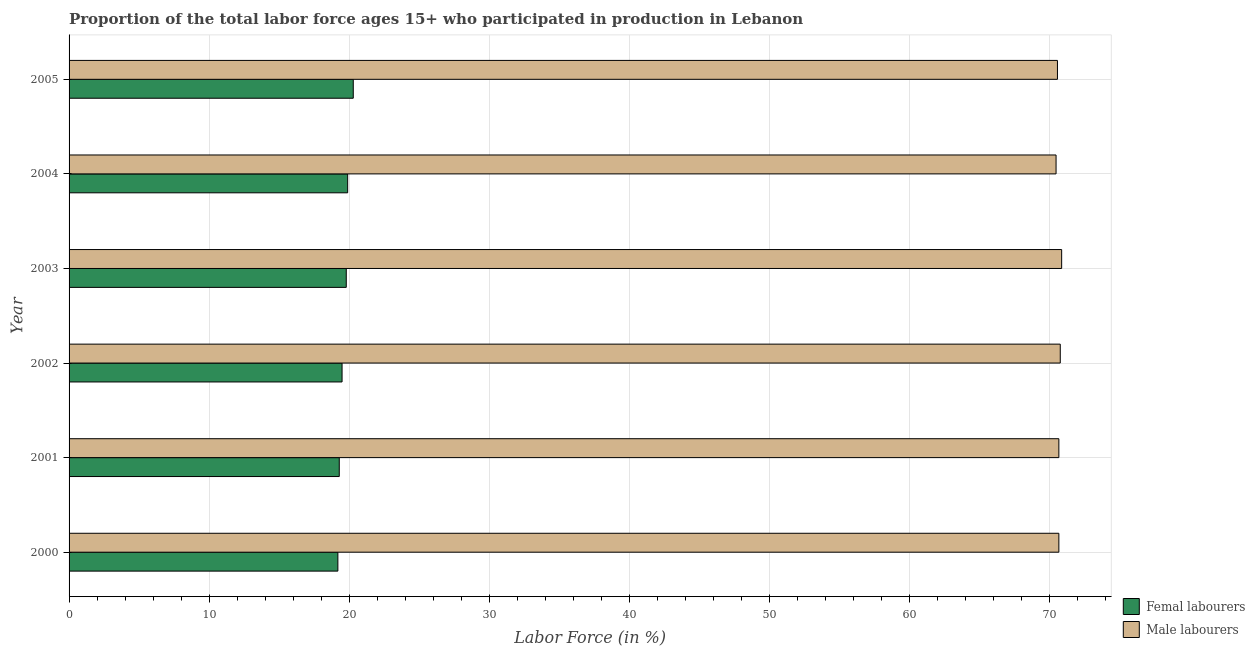How many different coloured bars are there?
Keep it short and to the point. 2. How many groups of bars are there?
Provide a short and direct response. 6. How many bars are there on the 4th tick from the top?
Your response must be concise. 2. How many bars are there on the 3rd tick from the bottom?
Keep it short and to the point. 2. In how many cases, is the number of bars for a given year not equal to the number of legend labels?
Provide a short and direct response. 0. What is the percentage of female labor force in 2004?
Offer a very short reply. 19.9. Across all years, what is the maximum percentage of male labour force?
Your answer should be very brief. 70.9. Across all years, what is the minimum percentage of male labour force?
Provide a succinct answer. 70.5. In which year was the percentage of female labor force maximum?
Your answer should be very brief. 2005. What is the total percentage of female labor force in the graph?
Your response must be concise. 118. What is the difference between the percentage of male labour force in 2000 and that in 2002?
Keep it short and to the point. -0.1. What is the difference between the percentage of male labour force in 2000 and the percentage of female labor force in 2005?
Offer a very short reply. 50.4. What is the average percentage of male labour force per year?
Give a very brief answer. 70.7. In the year 2004, what is the difference between the percentage of female labor force and percentage of male labour force?
Make the answer very short. -50.6. In how many years, is the percentage of female labor force greater than 30 %?
Give a very brief answer. 0. What is the ratio of the percentage of male labour force in 2003 to that in 2004?
Provide a short and direct response. 1.01. What is the difference between the highest and the second highest percentage of female labor force?
Your response must be concise. 0.4. What is the difference between the highest and the lowest percentage of female labor force?
Provide a succinct answer. 1.1. What does the 2nd bar from the top in 2005 represents?
Your response must be concise. Femal labourers. What does the 2nd bar from the bottom in 2002 represents?
Your response must be concise. Male labourers. How many bars are there?
Offer a very short reply. 12. What is the difference between two consecutive major ticks on the X-axis?
Provide a succinct answer. 10. Does the graph contain grids?
Provide a short and direct response. Yes. Where does the legend appear in the graph?
Ensure brevity in your answer.  Bottom right. How many legend labels are there?
Your response must be concise. 2. How are the legend labels stacked?
Offer a terse response. Vertical. What is the title of the graph?
Provide a short and direct response. Proportion of the total labor force ages 15+ who participated in production in Lebanon. What is the label or title of the X-axis?
Provide a short and direct response. Labor Force (in %). What is the label or title of the Y-axis?
Your response must be concise. Year. What is the Labor Force (in %) of Femal labourers in 2000?
Your answer should be compact. 19.2. What is the Labor Force (in %) of Male labourers in 2000?
Provide a succinct answer. 70.7. What is the Labor Force (in %) of Femal labourers in 2001?
Your response must be concise. 19.3. What is the Labor Force (in %) in Male labourers in 2001?
Offer a terse response. 70.7. What is the Labor Force (in %) of Male labourers in 2002?
Keep it short and to the point. 70.8. What is the Labor Force (in %) of Femal labourers in 2003?
Your answer should be very brief. 19.8. What is the Labor Force (in %) of Male labourers in 2003?
Offer a very short reply. 70.9. What is the Labor Force (in %) of Femal labourers in 2004?
Offer a terse response. 19.9. What is the Labor Force (in %) in Male labourers in 2004?
Provide a short and direct response. 70.5. What is the Labor Force (in %) in Femal labourers in 2005?
Make the answer very short. 20.3. What is the Labor Force (in %) of Male labourers in 2005?
Provide a short and direct response. 70.6. Across all years, what is the maximum Labor Force (in %) of Femal labourers?
Your response must be concise. 20.3. Across all years, what is the maximum Labor Force (in %) of Male labourers?
Make the answer very short. 70.9. Across all years, what is the minimum Labor Force (in %) in Femal labourers?
Provide a succinct answer. 19.2. Across all years, what is the minimum Labor Force (in %) of Male labourers?
Make the answer very short. 70.5. What is the total Labor Force (in %) of Femal labourers in the graph?
Provide a short and direct response. 118. What is the total Labor Force (in %) of Male labourers in the graph?
Your answer should be very brief. 424.2. What is the difference between the Labor Force (in %) of Femal labourers in 2000 and that in 2001?
Make the answer very short. -0.1. What is the difference between the Labor Force (in %) of Male labourers in 2000 and that in 2001?
Ensure brevity in your answer.  0. What is the difference between the Labor Force (in %) of Femal labourers in 2000 and that in 2002?
Your response must be concise. -0.3. What is the difference between the Labor Force (in %) of Male labourers in 2000 and that in 2002?
Offer a terse response. -0.1. What is the difference between the Labor Force (in %) of Male labourers in 2000 and that in 2003?
Give a very brief answer. -0.2. What is the difference between the Labor Force (in %) in Femal labourers in 2000 and that in 2004?
Make the answer very short. -0.7. What is the difference between the Labor Force (in %) in Male labourers in 2000 and that in 2004?
Make the answer very short. 0.2. What is the difference between the Labor Force (in %) in Femal labourers in 2000 and that in 2005?
Keep it short and to the point. -1.1. What is the difference between the Labor Force (in %) in Male labourers in 2001 and that in 2002?
Make the answer very short. -0.1. What is the difference between the Labor Force (in %) in Femal labourers in 2001 and that in 2003?
Provide a short and direct response. -0.5. What is the difference between the Labor Force (in %) in Male labourers in 2001 and that in 2003?
Offer a terse response. -0.2. What is the difference between the Labor Force (in %) of Male labourers in 2001 and that in 2005?
Provide a succinct answer. 0.1. What is the difference between the Labor Force (in %) of Femal labourers in 2002 and that in 2003?
Offer a terse response. -0.3. What is the difference between the Labor Force (in %) of Male labourers in 2002 and that in 2003?
Your response must be concise. -0.1. What is the difference between the Labor Force (in %) in Femal labourers in 2002 and that in 2004?
Give a very brief answer. -0.4. What is the difference between the Labor Force (in %) of Male labourers in 2002 and that in 2004?
Offer a very short reply. 0.3. What is the difference between the Labor Force (in %) of Femal labourers in 2003 and that in 2004?
Make the answer very short. -0.1. What is the difference between the Labor Force (in %) in Male labourers in 2003 and that in 2004?
Give a very brief answer. 0.4. What is the difference between the Labor Force (in %) in Femal labourers in 2003 and that in 2005?
Offer a very short reply. -0.5. What is the difference between the Labor Force (in %) of Femal labourers in 2004 and that in 2005?
Your answer should be compact. -0.4. What is the difference between the Labor Force (in %) in Femal labourers in 2000 and the Labor Force (in %) in Male labourers in 2001?
Your answer should be compact. -51.5. What is the difference between the Labor Force (in %) in Femal labourers in 2000 and the Labor Force (in %) in Male labourers in 2002?
Make the answer very short. -51.6. What is the difference between the Labor Force (in %) of Femal labourers in 2000 and the Labor Force (in %) of Male labourers in 2003?
Ensure brevity in your answer.  -51.7. What is the difference between the Labor Force (in %) in Femal labourers in 2000 and the Labor Force (in %) in Male labourers in 2004?
Your response must be concise. -51.3. What is the difference between the Labor Force (in %) in Femal labourers in 2000 and the Labor Force (in %) in Male labourers in 2005?
Give a very brief answer. -51.4. What is the difference between the Labor Force (in %) in Femal labourers in 2001 and the Labor Force (in %) in Male labourers in 2002?
Give a very brief answer. -51.5. What is the difference between the Labor Force (in %) of Femal labourers in 2001 and the Labor Force (in %) of Male labourers in 2003?
Offer a terse response. -51.6. What is the difference between the Labor Force (in %) in Femal labourers in 2001 and the Labor Force (in %) in Male labourers in 2004?
Offer a terse response. -51.2. What is the difference between the Labor Force (in %) in Femal labourers in 2001 and the Labor Force (in %) in Male labourers in 2005?
Make the answer very short. -51.3. What is the difference between the Labor Force (in %) of Femal labourers in 2002 and the Labor Force (in %) of Male labourers in 2003?
Provide a succinct answer. -51.4. What is the difference between the Labor Force (in %) in Femal labourers in 2002 and the Labor Force (in %) in Male labourers in 2004?
Your answer should be compact. -51. What is the difference between the Labor Force (in %) in Femal labourers in 2002 and the Labor Force (in %) in Male labourers in 2005?
Ensure brevity in your answer.  -51.1. What is the difference between the Labor Force (in %) of Femal labourers in 2003 and the Labor Force (in %) of Male labourers in 2004?
Your response must be concise. -50.7. What is the difference between the Labor Force (in %) of Femal labourers in 2003 and the Labor Force (in %) of Male labourers in 2005?
Give a very brief answer. -50.8. What is the difference between the Labor Force (in %) of Femal labourers in 2004 and the Labor Force (in %) of Male labourers in 2005?
Your answer should be compact. -50.7. What is the average Labor Force (in %) in Femal labourers per year?
Provide a short and direct response. 19.67. What is the average Labor Force (in %) of Male labourers per year?
Your response must be concise. 70.7. In the year 2000, what is the difference between the Labor Force (in %) in Femal labourers and Labor Force (in %) in Male labourers?
Make the answer very short. -51.5. In the year 2001, what is the difference between the Labor Force (in %) of Femal labourers and Labor Force (in %) of Male labourers?
Your response must be concise. -51.4. In the year 2002, what is the difference between the Labor Force (in %) in Femal labourers and Labor Force (in %) in Male labourers?
Your answer should be very brief. -51.3. In the year 2003, what is the difference between the Labor Force (in %) of Femal labourers and Labor Force (in %) of Male labourers?
Give a very brief answer. -51.1. In the year 2004, what is the difference between the Labor Force (in %) of Femal labourers and Labor Force (in %) of Male labourers?
Offer a very short reply. -50.6. In the year 2005, what is the difference between the Labor Force (in %) in Femal labourers and Labor Force (in %) in Male labourers?
Provide a short and direct response. -50.3. What is the ratio of the Labor Force (in %) in Femal labourers in 2000 to that in 2002?
Offer a very short reply. 0.98. What is the ratio of the Labor Force (in %) of Femal labourers in 2000 to that in 2003?
Make the answer very short. 0.97. What is the ratio of the Labor Force (in %) of Male labourers in 2000 to that in 2003?
Keep it short and to the point. 1. What is the ratio of the Labor Force (in %) of Femal labourers in 2000 to that in 2004?
Provide a succinct answer. 0.96. What is the ratio of the Labor Force (in %) of Male labourers in 2000 to that in 2004?
Offer a terse response. 1. What is the ratio of the Labor Force (in %) in Femal labourers in 2000 to that in 2005?
Make the answer very short. 0.95. What is the ratio of the Labor Force (in %) of Femal labourers in 2001 to that in 2003?
Your response must be concise. 0.97. What is the ratio of the Labor Force (in %) of Male labourers in 2001 to that in 2003?
Offer a very short reply. 1. What is the ratio of the Labor Force (in %) in Femal labourers in 2001 to that in 2004?
Ensure brevity in your answer.  0.97. What is the ratio of the Labor Force (in %) of Femal labourers in 2001 to that in 2005?
Your response must be concise. 0.95. What is the ratio of the Labor Force (in %) of Male labourers in 2001 to that in 2005?
Offer a very short reply. 1. What is the ratio of the Labor Force (in %) of Male labourers in 2002 to that in 2003?
Provide a short and direct response. 1. What is the ratio of the Labor Force (in %) of Femal labourers in 2002 to that in 2004?
Your answer should be very brief. 0.98. What is the ratio of the Labor Force (in %) in Male labourers in 2002 to that in 2004?
Give a very brief answer. 1. What is the ratio of the Labor Force (in %) in Femal labourers in 2002 to that in 2005?
Your answer should be very brief. 0.96. What is the ratio of the Labor Force (in %) of Femal labourers in 2003 to that in 2004?
Offer a terse response. 0.99. What is the ratio of the Labor Force (in %) in Femal labourers in 2003 to that in 2005?
Give a very brief answer. 0.98. What is the ratio of the Labor Force (in %) in Femal labourers in 2004 to that in 2005?
Keep it short and to the point. 0.98. What is the difference between the highest and the second highest Labor Force (in %) in Male labourers?
Give a very brief answer. 0.1. What is the difference between the highest and the lowest Labor Force (in %) in Male labourers?
Your response must be concise. 0.4. 